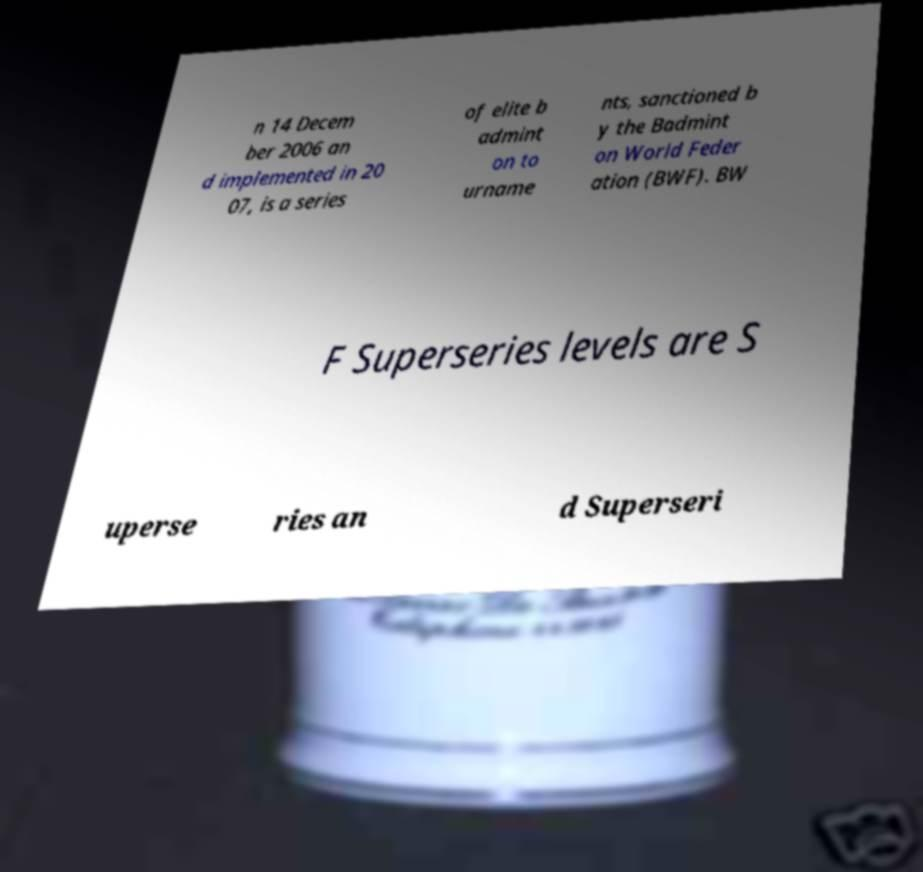Can you accurately transcribe the text from the provided image for me? n 14 Decem ber 2006 an d implemented in 20 07, is a series of elite b admint on to urname nts, sanctioned b y the Badmint on World Feder ation (BWF). BW F Superseries levels are S uperse ries an d Superseri 